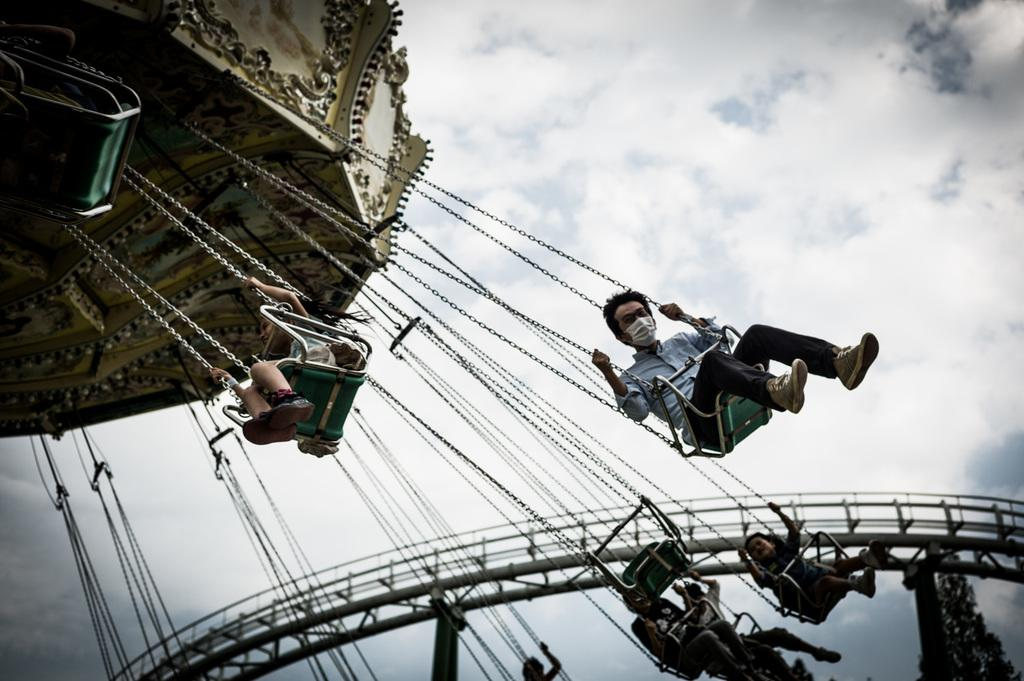What are the people in the image doing? The people in the image are sitting in the swings. What can be seen in the sky in the background of the image? There are clouds visible in the sky in the background of the image. What type of scarf is draped over the swing in the image? There is no scarf present in the image; the people are simply sitting in the swings. 